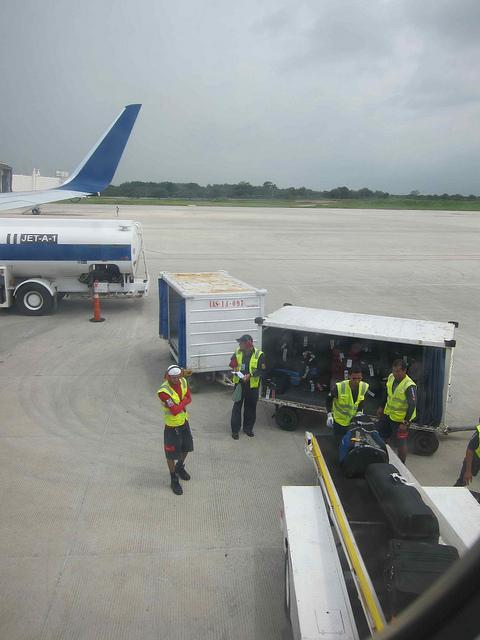What are they doing with the luggage? Please explain your reasoning. unloading. They are unloading the luggage and stuff. 